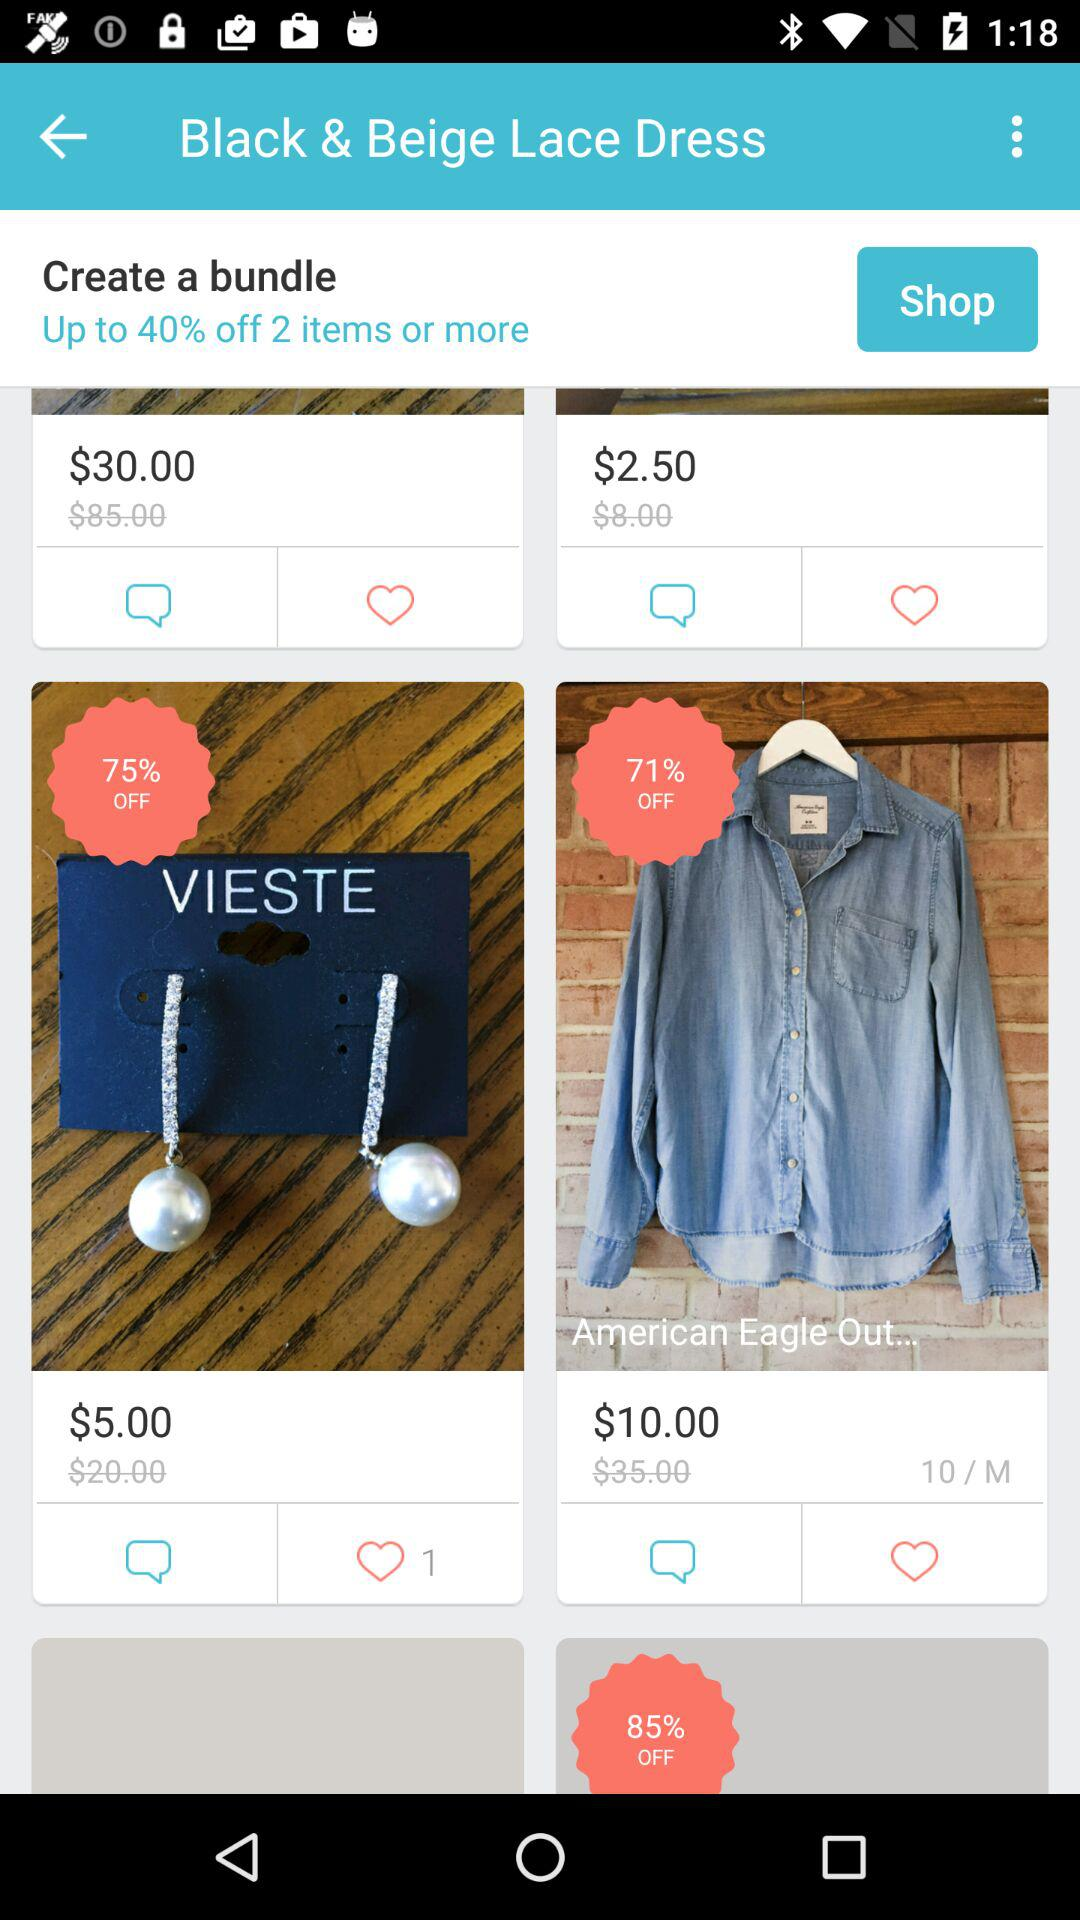What is the price of "American Eagle Out" after discount? The price of "American Eagle Out" after discount is $10.00. 